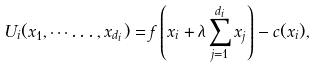<formula> <loc_0><loc_0><loc_500><loc_500>U _ { i } ( x _ { 1 } , \cdots \dots , x _ { d _ { i } } ) = f \left ( x _ { i } + \lambda \sum _ { j = 1 } ^ { d _ { i } } x _ { j } \right ) - c ( x _ { i } ) ,</formula> 